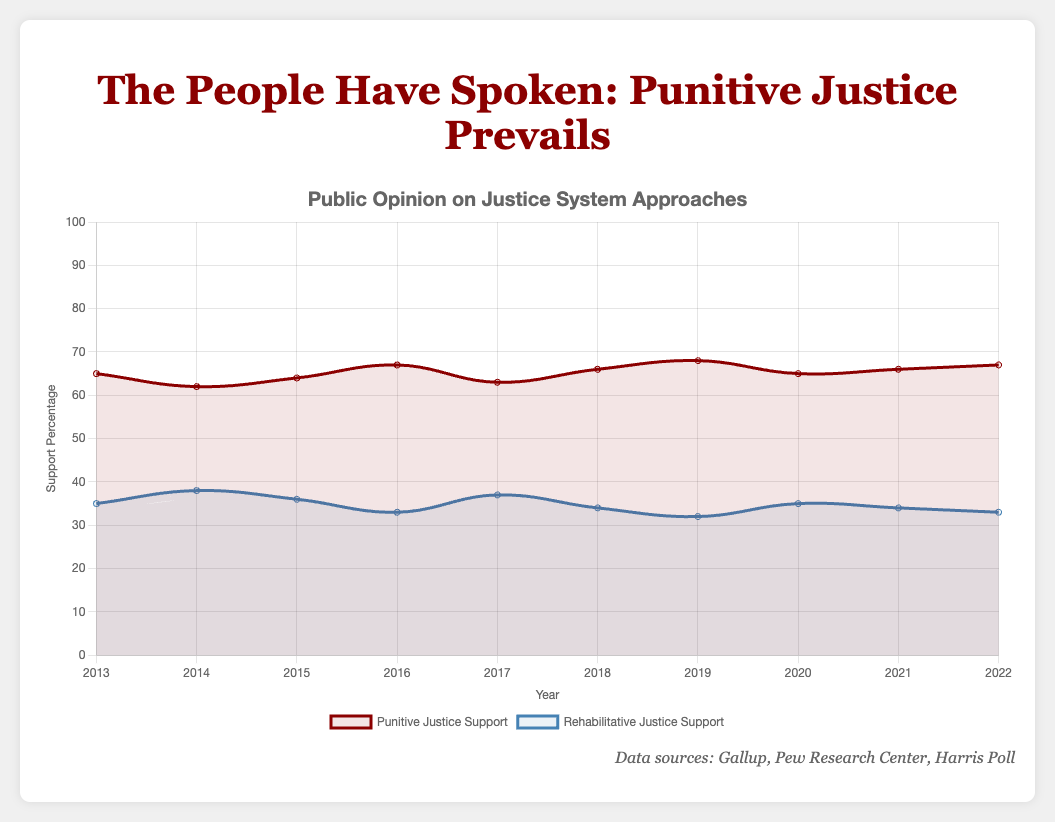What is the trend of support for punitive justice from 2013 to 2022? To determine the trend, observe the data points for punitive justice support for each year from 2013 to 2022. The percentages are 65, 62, 64, 67, 63, 66, 68, 65, 66, and 67, respectively. This shows a generally increasing trend with slight fluctuations.
Answer: Increasing with fluctuations Comparing the years, in which year did rehabilitative justice have the highest support, and what was the percentage? Look at the data points for rehabilitative justice support. The highest value is 38%, which occurs in 2014.
Answer: 2014, 38% In which year did the support for punitive justice see the largest increase compared to the previous year? To find this, calculate the differences between subsequent years' percentages for punitive justice. The largest increase is from 66% in 2018 to 68% in 2019, a change of 2%.
Answer: 2019 What is the average support for rehabilitative justice over the past decade? Calculate the average by summing the percentages for rehabilitative justice (35, 38, 36, 33, 37, 34, 32, 35, 34, 33) and dividing by the number of years (10). The total is (35 + 38 + 36 + 33 + 37 + 34 + 32 + 35 + 34 + 33) = 347. The average is 347/10 = 34.7%.
Answer: 34.7% How many times did support for punitive justice exceed 65% over the past decade? Count the number of years where the support for punitive justice is greater than 65%. These years are 2014 (67%), 2018 (66%), 2019 (68%), 2021 (66%), and 2022 (67%). So it happens 5 times.
Answer: 5 times What is the difference in support for punitive and rehabilitative justice in 2017? Subtract the percentage of rehabilitative justice support from punitive justice support in 2017. The values are 63% for punitive and 37% for rehabilitative justice. The difference is 63% - 37% = 26%.
Answer: 26% Which dataset generally shows higher values, punitive justice support or rehabilitative justice support? Compare the overall trends of both datasets. Punitive justice support consistently shows higher percentages than rehabilitative justice support across all years.
Answer: Punitive justice support What is the median value of punitive justice support over the past decade? Arrange the values of punitive justice support (65, 62, 64, 67, 63, 66, 68, 65, 66, 67) in ascending order (62, 63, 64, 65, 65, 66, 66, 67, 67, 68). The median is the average of the 5th and 6th values, (65+66)/2 = 65.5.
Answer: 65.5 By how much did support for rehabilitative justice decrease from 2013 to 2016? Subtract the percentage of rehabilitative justice support in 2016 from that in 2013. The values are 33% in 2016 and 35% in 2013. The decrease is 35% - 33% = 2%.
Answer: 2% Comparing 2018 and 2019, was the support for either justice system the same? Compare the percentages for both punitive and rehabilitative justice support in 2018 and 2019. For punitive (66% in 2018, 68% in 2019) and for rehabilitative (34% in 2018, 32% in 2019), the values are not the same.
Answer: No 